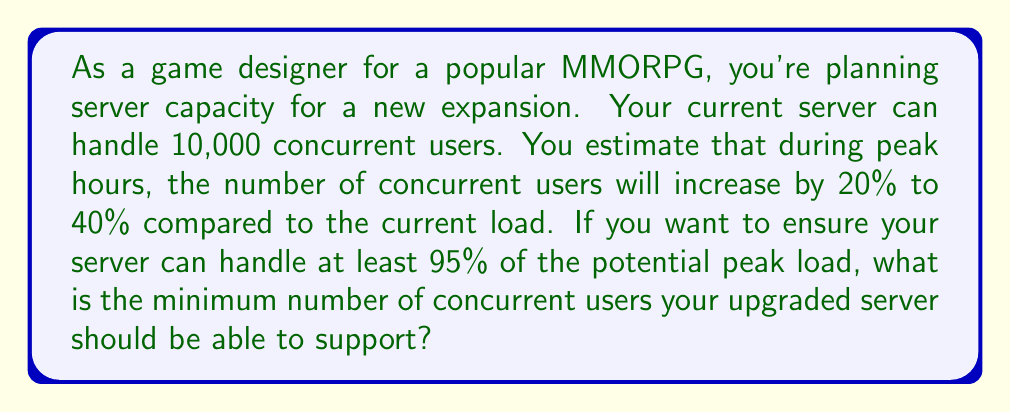Teach me how to tackle this problem. Let's approach this step-by-step:

1) First, we need to calculate the potential range of peak concurrent users:
   - Minimum increase: $10,000 \times 1.20 = 12,000$ users
   - Maximum increase: $10,000 \times 1.40 = 14,000$ users

2) The range of potential peak users is thus 12,000 to 14,000.

3) To find the 95th percentile of this range, we can use the formula:
   $$ \text{95th percentile} = \text{Min} + 0.95 \times (\text{Max} - \text{Min}) $$

4) Plugging in our values:
   $$ \text{95th percentile} = 12,000 + 0.95 \times (14,000 - 12,000) $$

5) Simplify:
   $$ \text{95th percentile} = 12,000 + 0.95 \times 2,000 = 12,000 + 1,900 = 13,900 $$

6) Since we're dealing with whole users, we round up to the nearest integer:
   $$ \text{Minimum server capacity} = \lceil 13,900 \rceil = 13,900 $$

Therefore, the upgraded server should be able to support at least 13,900 concurrent users to handle 95% of the potential peak load.
Answer: 13,900 concurrent users 